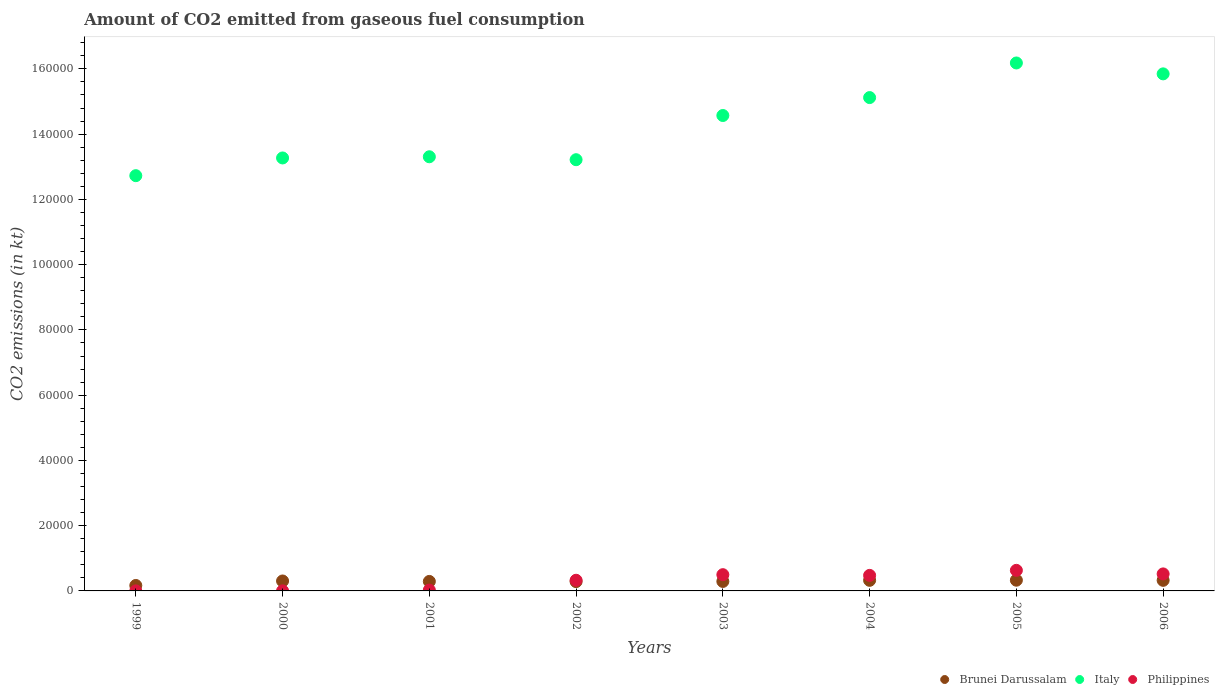What is the amount of CO2 emitted in Brunei Darussalam in 2002?
Give a very brief answer. 2852.93. Across all years, what is the maximum amount of CO2 emitted in Italy?
Provide a short and direct response. 1.62e+05. Across all years, what is the minimum amount of CO2 emitted in Italy?
Offer a very short reply. 1.27e+05. In which year was the amount of CO2 emitted in Philippines maximum?
Ensure brevity in your answer.  2005. What is the total amount of CO2 emitted in Italy in the graph?
Your answer should be compact. 1.14e+06. What is the difference between the amount of CO2 emitted in Brunei Darussalam in 2004 and that in 2006?
Provide a short and direct response. 3.67. What is the difference between the amount of CO2 emitted in Italy in 2006 and the amount of CO2 emitted in Philippines in 1999?
Make the answer very short. 1.58e+05. What is the average amount of CO2 emitted in Brunei Darussalam per year?
Offer a very short reply. 2894.18. In the year 2006, what is the difference between the amount of CO2 emitted in Italy and amount of CO2 emitted in Brunei Darussalam?
Your answer should be very brief. 1.55e+05. In how many years, is the amount of CO2 emitted in Brunei Darussalam greater than 16000 kt?
Provide a short and direct response. 0. What is the ratio of the amount of CO2 emitted in Philippines in 2001 to that in 2002?
Provide a short and direct response. 0.08. Is the difference between the amount of CO2 emitted in Italy in 2001 and 2006 greater than the difference between the amount of CO2 emitted in Brunei Darussalam in 2001 and 2006?
Your answer should be compact. No. What is the difference between the highest and the second highest amount of CO2 emitted in Brunei Darussalam?
Give a very brief answer. 40.34. What is the difference between the highest and the lowest amount of CO2 emitted in Italy?
Your answer should be very brief. 3.45e+04. In how many years, is the amount of CO2 emitted in Brunei Darussalam greater than the average amount of CO2 emitted in Brunei Darussalam taken over all years?
Provide a succinct answer. 6. Does the amount of CO2 emitted in Italy monotonically increase over the years?
Keep it short and to the point. No. Is the amount of CO2 emitted in Brunei Darussalam strictly less than the amount of CO2 emitted in Philippines over the years?
Provide a short and direct response. No. How many dotlines are there?
Provide a succinct answer. 3. How many years are there in the graph?
Keep it short and to the point. 8. What is the difference between two consecutive major ticks on the Y-axis?
Ensure brevity in your answer.  2.00e+04. Does the graph contain any zero values?
Your answer should be very brief. No. Does the graph contain grids?
Offer a very short reply. No. Where does the legend appear in the graph?
Your answer should be very brief. Bottom right. What is the title of the graph?
Your answer should be very brief. Amount of CO2 emitted from gaseous fuel consumption. What is the label or title of the X-axis?
Keep it short and to the point. Years. What is the label or title of the Y-axis?
Make the answer very short. CO2 emissions (in kt). What is the CO2 emissions (in kt) in Brunei Darussalam in 1999?
Provide a succinct answer. 1668.48. What is the CO2 emissions (in kt) in Italy in 1999?
Offer a terse response. 1.27e+05. What is the CO2 emissions (in kt) of Philippines in 1999?
Provide a succinct answer. 14.67. What is the CO2 emissions (in kt) in Brunei Darussalam in 2000?
Offer a very short reply. 3047.28. What is the CO2 emissions (in kt) of Italy in 2000?
Provide a short and direct response. 1.33e+05. What is the CO2 emissions (in kt) in Philippines in 2000?
Your response must be concise. 18.34. What is the CO2 emissions (in kt) in Brunei Darussalam in 2001?
Your response must be concise. 2907.93. What is the CO2 emissions (in kt) of Italy in 2001?
Offer a terse response. 1.33e+05. What is the CO2 emissions (in kt) of Philippines in 2001?
Your answer should be compact. 260.36. What is the CO2 emissions (in kt) in Brunei Darussalam in 2002?
Ensure brevity in your answer.  2852.93. What is the CO2 emissions (in kt) in Italy in 2002?
Give a very brief answer. 1.32e+05. What is the CO2 emissions (in kt) in Philippines in 2002?
Keep it short and to the point. 3267.3. What is the CO2 emissions (in kt) of Brunei Darussalam in 2003?
Provide a succinct answer. 2904.26. What is the CO2 emissions (in kt) in Italy in 2003?
Provide a succinct answer. 1.46e+05. What is the CO2 emissions (in kt) in Philippines in 2003?
Ensure brevity in your answer.  4979.79. What is the CO2 emissions (in kt) of Brunei Darussalam in 2004?
Your answer should be very brief. 3245.3. What is the CO2 emissions (in kt) in Italy in 2004?
Keep it short and to the point. 1.51e+05. What is the CO2 emissions (in kt) of Philippines in 2004?
Your answer should be very brief. 4763.43. What is the CO2 emissions (in kt) in Brunei Darussalam in 2005?
Your response must be concise. 3285.63. What is the CO2 emissions (in kt) in Italy in 2005?
Make the answer very short. 1.62e+05. What is the CO2 emissions (in kt) in Philippines in 2005?
Give a very brief answer. 6307.24. What is the CO2 emissions (in kt) of Brunei Darussalam in 2006?
Offer a very short reply. 3241.63. What is the CO2 emissions (in kt) in Italy in 2006?
Your answer should be compact. 1.58e+05. What is the CO2 emissions (in kt) of Philippines in 2006?
Make the answer very short. 5214.47. Across all years, what is the maximum CO2 emissions (in kt) of Brunei Darussalam?
Offer a terse response. 3285.63. Across all years, what is the maximum CO2 emissions (in kt) of Italy?
Your response must be concise. 1.62e+05. Across all years, what is the maximum CO2 emissions (in kt) of Philippines?
Ensure brevity in your answer.  6307.24. Across all years, what is the minimum CO2 emissions (in kt) in Brunei Darussalam?
Make the answer very short. 1668.48. Across all years, what is the minimum CO2 emissions (in kt) of Italy?
Make the answer very short. 1.27e+05. Across all years, what is the minimum CO2 emissions (in kt) of Philippines?
Your response must be concise. 14.67. What is the total CO2 emissions (in kt) of Brunei Darussalam in the graph?
Ensure brevity in your answer.  2.32e+04. What is the total CO2 emissions (in kt) in Italy in the graph?
Provide a succinct answer. 1.14e+06. What is the total CO2 emissions (in kt) in Philippines in the graph?
Your response must be concise. 2.48e+04. What is the difference between the CO2 emissions (in kt) in Brunei Darussalam in 1999 and that in 2000?
Keep it short and to the point. -1378.79. What is the difference between the CO2 emissions (in kt) of Italy in 1999 and that in 2000?
Your answer should be very brief. -5430.83. What is the difference between the CO2 emissions (in kt) of Philippines in 1999 and that in 2000?
Give a very brief answer. -3.67. What is the difference between the CO2 emissions (in kt) in Brunei Darussalam in 1999 and that in 2001?
Offer a terse response. -1239.45. What is the difference between the CO2 emissions (in kt) of Italy in 1999 and that in 2001?
Ensure brevity in your answer.  -5793.86. What is the difference between the CO2 emissions (in kt) of Philippines in 1999 and that in 2001?
Ensure brevity in your answer.  -245.69. What is the difference between the CO2 emissions (in kt) in Brunei Darussalam in 1999 and that in 2002?
Provide a succinct answer. -1184.44. What is the difference between the CO2 emissions (in kt) in Italy in 1999 and that in 2002?
Provide a succinct answer. -4895.44. What is the difference between the CO2 emissions (in kt) in Philippines in 1999 and that in 2002?
Provide a short and direct response. -3252.63. What is the difference between the CO2 emissions (in kt) of Brunei Darussalam in 1999 and that in 2003?
Your response must be concise. -1235.78. What is the difference between the CO2 emissions (in kt) of Italy in 1999 and that in 2003?
Keep it short and to the point. -1.84e+04. What is the difference between the CO2 emissions (in kt) of Philippines in 1999 and that in 2003?
Keep it short and to the point. -4965.12. What is the difference between the CO2 emissions (in kt) of Brunei Darussalam in 1999 and that in 2004?
Give a very brief answer. -1576.81. What is the difference between the CO2 emissions (in kt) in Italy in 1999 and that in 2004?
Ensure brevity in your answer.  -2.39e+04. What is the difference between the CO2 emissions (in kt) of Philippines in 1999 and that in 2004?
Your answer should be compact. -4748.77. What is the difference between the CO2 emissions (in kt) in Brunei Darussalam in 1999 and that in 2005?
Offer a very short reply. -1617.15. What is the difference between the CO2 emissions (in kt) in Italy in 1999 and that in 2005?
Offer a terse response. -3.45e+04. What is the difference between the CO2 emissions (in kt) of Philippines in 1999 and that in 2005?
Provide a succinct answer. -6292.57. What is the difference between the CO2 emissions (in kt) in Brunei Darussalam in 1999 and that in 2006?
Offer a terse response. -1573.14. What is the difference between the CO2 emissions (in kt) of Italy in 1999 and that in 2006?
Offer a very short reply. -3.12e+04. What is the difference between the CO2 emissions (in kt) of Philippines in 1999 and that in 2006?
Your answer should be compact. -5199.81. What is the difference between the CO2 emissions (in kt) of Brunei Darussalam in 2000 and that in 2001?
Give a very brief answer. 139.35. What is the difference between the CO2 emissions (in kt) in Italy in 2000 and that in 2001?
Your answer should be compact. -363.03. What is the difference between the CO2 emissions (in kt) in Philippines in 2000 and that in 2001?
Keep it short and to the point. -242.02. What is the difference between the CO2 emissions (in kt) of Brunei Darussalam in 2000 and that in 2002?
Provide a succinct answer. 194.35. What is the difference between the CO2 emissions (in kt) in Italy in 2000 and that in 2002?
Your answer should be very brief. 535.38. What is the difference between the CO2 emissions (in kt) of Philippines in 2000 and that in 2002?
Provide a succinct answer. -3248.96. What is the difference between the CO2 emissions (in kt) in Brunei Darussalam in 2000 and that in 2003?
Ensure brevity in your answer.  143.01. What is the difference between the CO2 emissions (in kt) of Italy in 2000 and that in 2003?
Offer a very short reply. -1.30e+04. What is the difference between the CO2 emissions (in kt) of Philippines in 2000 and that in 2003?
Offer a terse response. -4961.45. What is the difference between the CO2 emissions (in kt) of Brunei Darussalam in 2000 and that in 2004?
Offer a very short reply. -198.02. What is the difference between the CO2 emissions (in kt) in Italy in 2000 and that in 2004?
Your response must be concise. -1.85e+04. What is the difference between the CO2 emissions (in kt) of Philippines in 2000 and that in 2004?
Your response must be concise. -4745.1. What is the difference between the CO2 emissions (in kt) in Brunei Darussalam in 2000 and that in 2005?
Give a very brief answer. -238.35. What is the difference between the CO2 emissions (in kt) in Italy in 2000 and that in 2005?
Offer a terse response. -2.91e+04. What is the difference between the CO2 emissions (in kt) of Philippines in 2000 and that in 2005?
Offer a very short reply. -6288.9. What is the difference between the CO2 emissions (in kt) in Brunei Darussalam in 2000 and that in 2006?
Keep it short and to the point. -194.35. What is the difference between the CO2 emissions (in kt) of Italy in 2000 and that in 2006?
Your response must be concise. -2.58e+04. What is the difference between the CO2 emissions (in kt) of Philippines in 2000 and that in 2006?
Your response must be concise. -5196.14. What is the difference between the CO2 emissions (in kt) of Brunei Darussalam in 2001 and that in 2002?
Provide a succinct answer. 55.01. What is the difference between the CO2 emissions (in kt) of Italy in 2001 and that in 2002?
Provide a succinct answer. 898.41. What is the difference between the CO2 emissions (in kt) in Philippines in 2001 and that in 2002?
Ensure brevity in your answer.  -3006.94. What is the difference between the CO2 emissions (in kt) of Brunei Darussalam in 2001 and that in 2003?
Offer a terse response. 3.67. What is the difference between the CO2 emissions (in kt) in Italy in 2001 and that in 2003?
Give a very brief answer. -1.26e+04. What is the difference between the CO2 emissions (in kt) in Philippines in 2001 and that in 2003?
Make the answer very short. -4719.43. What is the difference between the CO2 emissions (in kt) in Brunei Darussalam in 2001 and that in 2004?
Your response must be concise. -337.36. What is the difference between the CO2 emissions (in kt) in Italy in 2001 and that in 2004?
Give a very brief answer. -1.81e+04. What is the difference between the CO2 emissions (in kt) of Philippines in 2001 and that in 2004?
Give a very brief answer. -4503.08. What is the difference between the CO2 emissions (in kt) of Brunei Darussalam in 2001 and that in 2005?
Give a very brief answer. -377.7. What is the difference between the CO2 emissions (in kt) in Italy in 2001 and that in 2005?
Give a very brief answer. -2.87e+04. What is the difference between the CO2 emissions (in kt) in Philippines in 2001 and that in 2005?
Offer a very short reply. -6046.88. What is the difference between the CO2 emissions (in kt) of Brunei Darussalam in 2001 and that in 2006?
Make the answer very short. -333.7. What is the difference between the CO2 emissions (in kt) in Italy in 2001 and that in 2006?
Keep it short and to the point. -2.54e+04. What is the difference between the CO2 emissions (in kt) in Philippines in 2001 and that in 2006?
Give a very brief answer. -4954.12. What is the difference between the CO2 emissions (in kt) of Brunei Darussalam in 2002 and that in 2003?
Provide a short and direct response. -51.34. What is the difference between the CO2 emissions (in kt) in Italy in 2002 and that in 2003?
Make the answer very short. -1.35e+04. What is the difference between the CO2 emissions (in kt) of Philippines in 2002 and that in 2003?
Your answer should be very brief. -1712.49. What is the difference between the CO2 emissions (in kt) in Brunei Darussalam in 2002 and that in 2004?
Offer a very short reply. -392.37. What is the difference between the CO2 emissions (in kt) of Italy in 2002 and that in 2004?
Provide a short and direct response. -1.90e+04. What is the difference between the CO2 emissions (in kt) in Philippines in 2002 and that in 2004?
Your response must be concise. -1496.14. What is the difference between the CO2 emissions (in kt) in Brunei Darussalam in 2002 and that in 2005?
Make the answer very short. -432.71. What is the difference between the CO2 emissions (in kt) of Italy in 2002 and that in 2005?
Provide a succinct answer. -2.96e+04. What is the difference between the CO2 emissions (in kt) of Philippines in 2002 and that in 2005?
Ensure brevity in your answer.  -3039.94. What is the difference between the CO2 emissions (in kt) in Brunei Darussalam in 2002 and that in 2006?
Offer a terse response. -388.7. What is the difference between the CO2 emissions (in kt) of Italy in 2002 and that in 2006?
Your response must be concise. -2.63e+04. What is the difference between the CO2 emissions (in kt) of Philippines in 2002 and that in 2006?
Provide a succinct answer. -1947.18. What is the difference between the CO2 emissions (in kt) of Brunei Darussalam in 2003 and that in 2004?
Provide a succinct answer. -341.03. What is the difference between the CO2 emissions (in kt) in Italy in 2003 and that in 2004?
Provide a succinct answer. -5493.17. What is the difference between the CO2 emissions (in kt) of Philippines in 2003 and that in 2004?
Your response must be concise. 216.35. What is the difference between the CO2 emissions (in kt) in Brunei Darussalam in 2003 and that in 2005?
Offer a terse response. -381.37. What is the difference between the CO2 emissions (in kt) of Italy in 2003 and that in 2005?
Give a very brief answer. -1.61e+04. What is the difference between the CO2 emissions (in kt) of Philippines in 2003 and that in 2005?
Your response must be concise. -1327.45. What is the difference between the CO2 emissions (in kt) in Brunei Darussalam in 2003 and that in 2006?
Give a very brief answer. -337.36. What is the difference between the CO2 emissions (in kt) of Italy in 2003 and that in 2006?
Ensure brevity in your answer.  -1.28e+04. What is the difference between the CO2 emissions (in kt) in Philippines in 2003 and that in 2006?
Give a very brief answer. -234.69. What is the difference between the CO2 emissions (in kt) in Brunei Darussalam in 2004 and that in 2005?
Offer a terse response. -40.34. What is the difference between the CO2 emissions (in kt) in Italy in 2004 and that in 2005?
Your answer should be very brief. -1.06e+04. What is the difference between the CO2 emissions (in kt) of Philippines in 2004 and that in 2005?
Offer a terse response. -1543.81. What is the difference between the CO2 emissions (in kt) in Brunei Darussalam in 2004 and that in 2006?
Provide a succinct answer. 3.67. What is the difference between the CO2 emissions (in kt) in Italy in 2004 and that in 2006?
Ensure brevity in your answer.  -7267.99. What is the difference between the CO2 emissions (in kt) in Philippines in 2004 and that in 2006?
Make the answer very short. -451.04. What is the difference between the CO2 emissions (in kt) in Brunei Darussalam in 2005 and that in 2006?
Make the answer very short. 44. What is the difference between the CO2 emissions (in kt) in Italy in 2005 and that in 2006?
Offer a very short reply. 3340.64. What is the difference between the CO2 emissions (in kt) of Philippines in 2005 and that in 2006?
Ensure brevity in your answer.  1092.77. What is the difference between the CO2 emissions (in kt) of Brunei Darussalam in 1999 and the CO2 emissions (in kt) of Italy in 2000?
Ensure brevity in your answer.  -1.31e+05. What is the difference between the CO2 emissions (in kt) of Brunei Darussalam in 1999 and the CO2 emissions (in kt) of Philippines in 2000?
Provide a succinct answer. 1650.15. What is the difference between the CO2 emissions (in kt) in Italy in 1999 and the CO2 emissions (in kt) in Philippines in 2000?
Your answer should be very brief. 1.27e+05. What is the difference between the CO2 emissions (in kt) of Brunei Darussalam in 1999 and the CO2 emissions (in kt) of Italy in 2001?
Keep it short and to the point. -1.31e+05. What is the difference between the CO2 emissions (in kt) in Brunei Darussalam in 1999 and the CO2 emissions (in kt) in Philippines in 2001?
Ensure brevity in your answer.  1408.13. What is the difference between the CO2 emissions (in kt) of Italy in 1999 and the CO2 emissions (in kt) of Philippines in 2001?
Provide a short and direct response. 1.27e+05. What is the difference between the CO2 emissions (in kt) of Brunei Darussalam in 1999 and the CO2 emissions (in kt) of Italy in 2002?
Your response must be concise. -1.30e+05. What is the difference between the CO2 emissions (in kt) in Brunei Darussalam in 1999 and the CO2 emissions (in kt) in Philippines in 2002?
Provide a short and direct response. -1598.81. What is the difference between the CO2 emissions (in kt) of Italy in 1999 and the CO2 emissions (in kt) of Philippines in 2002?
Give a very brief answer. 1.24e+05. What is the difference between the CO2 emissions (in kt) in Brunei Darussalam in 1999 and the CO2 emissions (in kt) in Italy in 2003?
Make the answer very short. -1.44e+05. What is the difference between the CO2 emissions (in kt) of Brunei Darussalam in 1999 and the CO2 emissions (in kt) of Philippines in 2003?
Make the answer very short. -3311.3. What is the difference between the CO2 emissions (in kt) of Italy in 1999 and the CO2 emissions (in kt) of Philippines in 2003?
Provide a succinct answer. 1.22e+05. What is the difference between the CO2 emissions (in kt) in Brunei Darussalam in 1999 and the CO2 emissions (in kt) in Italy in 2004?
Your answer should be compact. -1.50e+05. What is the difference between the CO2 emissions (in kt) of Brunei Darussalam in 1999 and the CO2 emissions (in kt) of Philippines in 2004?
Your response must be concise. -3094.95. What is the difference between the CO2 emissions (in kt) of Italy in 1999 and the CO2 emissions (in kt) of Philippines in 2004?
Give a very brief answer. 1.23e+05. What is the difference between the CO2 emissions (in kt) in Brunei Darussalam in 1999 and the CO2 emissions (in kt) in Italy in 2005?
Offer a very short reply. -1.60e+05. What is the difference between the CO2 emissions (in kt) of Brunei Darussalam in 1999 and the CO2 emissions (in kt) of Philippines in 2005?
Provide a short and direct response. -4638.76. What is the difference between the CO2 emissions (in kt) of Italy in 1999 and the CO2 emissions (in kt) of Philippines in 2005?
Ensure brevity in your answer.  1.21e+05. What is the difference between the CO2 emissions (in kt) of Brunei Darussalam in 1999 and the CO2 emissions (in kt) of Italy in 2006?
Give a very brief answer. -1.57e+05. What is the difference between the CO2 emissions (in kt) in Brunei Darussalam in 1999 and the CO2 emissions (in kt) in Philippines in 2006?
Ensure brevity in your answer.  -3545.99. What is the difference between the CO2 emissions (in kt) of Italy in 1999 and the CO2 emissions (in kt) of Philippines in 2006?
Your answer should be very brief. 1.22e+05. What is the difference between the CO2 emissions (in kt) of Brunei Darussalam in 2000 and the CO2 emissions (in kt) of Italy in 2001?
Offer a terse response. -1.30e+05. What is the difference between the CO2 emissions (in kt) in Brunei Darussalam in 2000 and the CO2 emissions (in kt) in Philippines in 2001?
Provide a succinct answer. 2786.92. What is the difference between the CO2 emissions (in kt) of Italy in 2000 and the CO2 emissions (in kt) of Philippines in 2001?
Offer a very short reply. 1.32e+05. What is the difference between the CO2 emissions (in kt) in Brunei Darussalam in 2000 and the CO2 emissions (in kt) in Italy in 2002?
Make the answer very short. -1.29e+05. What is the difference between the CO2 emissions (in kt) in Brunei Darussalam in 2000 and the CO2 emissions (in kt) in Philippines in 2002?
Ensure brevity in your answer.  -220.02. What is the difference between the CO2 emissions (in kt) in Italy in 2000 and the CO2 emissions (in kt) in Philippines in 2002?
Offer a very short reply. 1.29e+05. What is the difference between the CO2 emissions (in kt) in Brunei Darussalam in 2000 and the CO2 emissions (in kt) in Italy in 2003?
Your answer should be very brief. -1.43e+05. What is the difference between the CO2 emissions (in kt) of Brunei Darussalam in 2000 and the CO2 emissions (in kt) of Philippines in 2003?
Ensure brevity in your answer.  -1932.51. What is the difference between the CO2 emissions (in kt) of Italy in 2000 and the CO2 emissions (in kt) of Philippines in 2003?
Provide a succinct answer. 1.28e+05. What is the difference between the CO2 emissions (in kt) in Brunei Darussalam in 2000 and the CO2 emissions (in kt) in Italy in 2004?
Provide a short and direct response. -1.48e+05. What is the difference between the CO2 emissions (in kt) in Brunei Darussalam in 2000 and the CO2 emissions (in kt) in Philippines in 2004?
Provide a short and direct response. -1716.16. What is the difference between the CO2 emissions (in kt) of Italy in 2000 and the CO2 emissions (in kt) of Philippines in 2004?
Offer a very short reply. 1.28e+05. What is the difference between the CO2 emissions (in kt) of Brunei Darussalam in 2000 and the CO2 emissions (in kt) of Italy in 2005?
Provide a succinct answer. -1.59e+05. What is the difference between the CO2 emissions (in kt) of Brunei Darussalam in 2000 and the CO2 emissions (in kt) of Philippines in 2005?
Provide a short and direct response. -3259.96. What is the difference between the CO2 emissions (in kt) in Italy in 2000 and the CO2 emissions (in kt) in Philippines in 2005?
Provide a succinct answer. 1.26e+05. What is the difference between the CO2 emissions (in kt) of Brunei Darussalam in 2000 and the CO2 emissions (in kt) of Italy in 2006?
Your answer should be compact. -1.55e+05. What is the difference between the CO2 emissions (in kt) in Brunei Darussalam in 2000 and the CO2 emissions (in kt) in Philippines in 2006?
Give a very brief answer. -2167.2. What is the difference between the CO2 emissions (in kt) of Italy in 2000 and the CO2 emissions (in kt) of Philippines in 2006?
Your answer should be very brief. 1.27e+05. What is the difference between the CO2 emissions (in kt) of Brunei Darussalam in 2001 and the CO2 emissions (in kt) of Italy in 2002?
Give a very brief answer. -1.29e+05. What is the difference between the CO2 emissions (in kt) in Brunei Darussalam in 2001 and the CO2 emissions (in kt) in Philippines in 2002?
Make the answer very short. -359.37. What is the difference between the CO2 emissions (in kt) of Italy in 2001 and the CO2 emissions (in kt) of Philippines in 2002?
Give a very brief answer. 1.30e+05. What is the difference between the CO2 emissions (in kt) in Brunei Darussalam in 2001 and the CO2 emissions (in kt) in Italy in 2003?
Your answer should be very brief. -1.43e+05. What is the difference between the CO2 emissions (in kt) of Brunei Darussalam in 2001 and the CO2 emissions (in kt) of Philippines in 2003?
Your response must be concise. -2071.86. What is the difference between the CO2 emissions (in kt) in Italy in 2001 and the CO2 emissions (in kt) in Philippines in 2003?
Provide a succinct answer. 1.28e+05. What is the difference between the CO2 emissions (in kt) of Brunei Darussalam in 2001 and the CO2 emissions (in kt) of Italy in 2004?
Keep it short and to the point. -1.48e+05. What is the difference between the CO2 emissions (in kt) of Brunei Darussalam in 2001 and the CO2 emissions (in kt) of Philippines in 2004?
Offer a terse response. -1855.5. What is the difference between the CO2 emissions (in kt) in Italy in 2001 and the CO2 emissions (in kt) in Philippines in 2004?
Your response must be concise. 1.28e+05. What is the difference between the CO2 emissions (in kt) of Brunei Darussalam in 2001 and the CO2 emissions (in kt) of Italy in 2005?
Provide a short and direct response. -1.59e+05. What is the difference between the CO2 emissions (in kt) of Brunei Darussalam in 2001 and the CO2 emissions (in kt) of Philippines in 2005?
Keep it short and to the point. -3399.31. What is the difference between the CO2 emissions (in kt) in Italy in 2001 and the CO2 emissions (in kt) in Philippines in 2005?
Give a very brief answer. 1.27e+05. What is the difference between the CO2 emissions (in kt) in Brunei Darussalam in 2001 and the CO2 emissions (in kt) in Italy in 2006?
Give a very brief answer. -1.56e+05. What is the difference between the CO2 emissions (in kt) of Brunei Darussalam in 2001 and the CO2 emissions (in kt) of Philippines in 2006?
Your response must be concise. -2306.54. What is the difference between the CO2 emissions (in kt) in Italy in 2001 and the CO2 emissions (in kt) in Philippines in 2006?
Offer a very short reply. 1.28e+05. What is the difference between the CO2 emissions (in kt) in Brunei Darussalam in 2002 and the CO2 emissions (in kt) in Italy in 2003?
Provide a succinct answer. -1.43e+05. What is the difference between the CO2 emissions (in kt) in Brunei Darussalam in 2002 and the CO2 emissions (in kt) in Philippines in 2003?
Give a very brief answer. -2126.86. What is the difference between the CO2 emissions (in kt) of Italy in 2002 and the CO2 emissions (in kt) of Philippines in 2003?
Make the answer very short. 1.27e+05. What is the difference between the CO2 emissions (in kt) in Brunei Darussalam in 2002 and the CO2 emissions (in kt) in Italy in 2004?
Keep it short and to the point. -1.48e+05. What is the difference between the CO2 emissions (in kt) in Brunei Darussalam in 2002 and the CO2 emissions (in kt) in Philippines in 2004?
Provide a succinct answer. -1910.51. What is the difference between the CO2 emissions (in kt) in Italy in 2002 and the CO2 emissions (in kt) in Philippines in 2004?
Your response must be concise. 1.27e+05. What is the difference between the CO2 emissions (in kt) in Brunei Darussalam in 2002 and the CO2 emissions (in kt) in Italy in 2005?
Your response must be concise. -1.59e+05. What is the difference between the CO2 emissions (in kt) of Brunei Darussalam in 2002 and the CO2 emissions (in kt) of Philippines in 2005?
Provide a short and direct response. -3454.31. What is the difference between the CO2 emissions (in kt) of Italy in 2002 and the CO2 emissions (in kt) of Philippines in 2005?
Keep it short and to the point. 1.26e+05. What is the difference between the CO2 emissions (in kt) of Brunei Darussalam in 2002 and the CO2 emissions (in kt) of Italy in 2006?
Make the answer very short. -1.56e+05. What is the difference between the CO2 emissions (in kt) in Brunei Darussalam in 2002 and the CO2 emissions (in kt) in Philippines in 2006?
Keep it short and to the point. -2361.55. What is the difference between the CO2 emissions (in kt) in Italy in 2002 and the CO2 emissions (in kt) in Philippines in 2006?
Provide a succinct answer. 1.27e+05. What is the difference between the CO2 emissions (in kt) of Brunei Darussalam in 2003 and the CO2 emissions (in kt) of Italy in 2004?
Your response must be concise. -1.48e+05. What is the difference between the CO2 emissions (in kt) of Brunei Darussalam in 2003 and the CO2 emissions (in kt) of Philippines in 2004?
Your answer should be very brief. -1859.17. What is the difference between the CO2 emissions (in kt) of Italy in 2003 and the CO2 emissions (in kt) of Philippines in 2004?
Your answer should be very brief. 1.41e+05. What is the difference between the CO2 emissions (in kt) in Brunei Darussalam in 2003 and the CO2 emissions (in kt) in Italy in 2005?
Provide a succinct answer. -1.59e+05. What is the difference between the CO2 emissions (in kt) in Brunei Darussalam in 2003 and the CO2 emissions (in kt) in Philippines in 2005?
Offer a terse response. -3402.98. What is the difference between the CO2 emissions (in kt) in Italy in 2003 and the CO2 emissions (in kt) in Philippines in 2005?
Provide a short and direct response. 1.39e+05. What is the difference between the CO2 emissions (in kt) in Brunei Darussalam in 2003 and the CO2 emissions (in kt) in Italy in 2006?
Your answer should be very brief. -1.56e+05. What is the difference between the CO2 emissions (in kt) in Brunei Darussalam in 2003 and the CO2 emissions (in kt) in Philippines in 2006?
Make the answer very short. -2310.21. What is the difference between the CO2 emissions (in kt) in Italy in 2003 and the CO2 emissions (in kt) in Philippines in 2006?
Offer a very short reply. 1.40e+05. What is the difference between the CO2 emissions (in kt) of Brunei Darussalam in 2004 and the CO2 emissions (in kt) of Italy in 2005?
Keep it short and to the point. -1.59e+05. What is the difference between the CO2 emissions (in kt) in Brunei Darussalam in 2004 and the CO2 emissions (in kt) in Philippines in 2005?
Your answer should be compact. -3061.95. What is the difference between the CO2 emissions (in kt) in Italy in 2004 and the CO2 emissions (in kt) in Philippines in 2005?
Your answer should be very brief. 1.45e+05. What is the difference between the CO2 emissions (in kt) of Brunei Darussalam in 2004 and the CO2 emissions (in kt) of Italy in 2006?
Your answer should be compact. -1.55e+05. What is the difference between the CO2 emissions (in kt) of Brunei Darussalam in 2004 and the CO2 emissions (in kt) of Philippines in 2006?
Your answer should be very brief. -1969.18. What is the difference between the CO2 emissions (in kt) in Italy in 2004 and the CO2 emissions (in kt) in Philippines in 2006?
Make the answer very short. 1.46e+05. What is the difference between the CO2 emissions (in kt) in Brunei Darussalam in 2005 and the CO2 emissions (in kt) in Italy in 2006?
Provide a succinct answer. -1.55e+05. What is the difference between the CO2 emissions (in kt) in Brunei Darussalam in 2005 and the CO2 emissions (in kt) in Philippines in 2006?
Offer a terse response. -1928.84. What is the difference between the CO2 emissions (in kt) of Italy in 2005 and the CO2 emissions (in kt) of Philippines in 2006?
Provide a succinct answer. 1.57e+05. What is the average CO2 emissions (in kt) in Brunei Darussalam per year?
Provide a short and direct response. 2894.18. What is the average CO2 emissions (in kt) in Italy per year?
Give a very brief answer. 1.43e+05. What is the average CO2 emissions (in kt) of Philippines per year?
Give a very brief answer. 3103.2. In the year 1999, what is the difference between the CO2 emissions (in kt) of Brunei Darussalam and CO2 emissions (in kt) of Italy?
Ensure brevity in your answer.  -1.26e+05. In the year 1999, what is the difference between the CO2 emissions (in kt) in Brunei Darussalam and CO2 emissions (in kt) in Philippines?
Make the answer very short. 1653.82. In the year 1999, what is the difference between the CO2 emissions (in kt) in Italy and CO2 emissions (in kt) in Philippines?
Offer a terse response. 1.27e+05. In the year 2000, what is the difference between the CO2 emissions (in kt) in Brunei Darussalam and CO2 emissions (in kt) in Italy?
Your response must be concise. -1.30e+05. In the year 2000, what is the difference between the CO2 emissions (in kt) in Brunei Darussalam and CO2 emissions (in kt) in Philippines?
Provide a short and direct response. 3028.94. In the year 2000, what is the difference between the CO2 emissions (in kt) in Italy and CO2 emissions (in kt) in Philippines?
Offer a terse response. 1.33e+05. In the year 2001, what is the difference between the CO2 emissions (in kt) in Brunei Darussalam and CO2 emissions (in kt) in Italy?
Provide a succinct answer. -1.30e+05. In the year 2001, what is the difference between the CO2 emissions (in kt) of Brunei Darussalam and CO2 emissions (in kt) of Philippines?
Your response must be concise. 2647.57. In the year 2001, what is the difference between the CO2 emissions (in kt) in Italy and CO2 emissions (in kt) in Philippines?
Your answer should be compact. 1.33e+05. In the year 2002, what is the difference between the CO2 emissions (in kt) of Brunei Darussalam and CO2 emissions (in kt) of Italy?
Give a very brief answer. -1.29e+05. In the year 2002, what is the difference between the CO2 emissions (in kt) of Brunei Darussalam and CO2 emissions (in kt) of Philippines?
Offer a very short reply. -414.37. In the year 2002, what is the difference between the CO2 emissions (in kt) of Italy and CO2 emissions (in kt) of Philippines?
Your answer should be compact. 1.29e+05. In the year 2003, what is the difference between the CO2 emissions (in kt) of Brunei Darussalam and CO2 emissions (in kt) of Italy?
Ensure brevity in your answer.  -1.43e+05. In the year 2003, what is the difference between the CO2 emissions (in kt) in Brunei Darussalam and CO2 emissions (in kt) in Philippines?
Give a very brief answer. -2075.52. In the year 2003, what is the difference between the CO2 emissions (in kt) of Italy and CO2 emissions (in kt) of Philippines?
Your answer should be very brief. 1.41e+05. In the year 2004, what is the difference between the CO2 emissions (in kt) in Brunei Darussalam and CO2 emissions (in kt) in Italy?
Provide a short and direct response. -1.48e+05. In the year 2004, what is the difference between the CO2 emissions (in kt) in Brunei Darussalam and CO2 emissions (in kt) in Philippines?
Offer a terse response. -1518.14. In the year 2004, what is the difference between the CO2 emissions (in kt) in Italy and CO2 emissions (in kt) in Philippines?
Provide a succinct answer. 1.46e+05. In the year 2005, what is the difference between the CO2 emissions (in kt) of Brunei Darussalam and CO2 emissions (in kt) of Italy?
Ensure brevity in your answer.  -1.59e+05. In the year 2005, what is the difference between the CO2 emissions (in kt) of Brunei Darussalam and CO2 emissions (in kt) of Philippines?
Your response must be concise. -3021.61. In the year 2005, what is the difference between the CO2 emissions (in kt) of Italy and CO2 emissions (in kt) of Philippines?
Your answer should be very brief. 1.56e+05. In the year 2006, what is the difference between the CO2 emissions (in kt) of Brunei Darussalam and CO2 emissions (in kt) of Italy?
Your answer should be very brief. -1.55e+05. In the year 2006, what is the difference between the CO2 emissions (in kt) in Brunei Darussalam and CO2 emissions (in kt) in Philippines?
Ensure brevity in your answer.  -1972.85. In the year 2006, what is the difference between the CO2 emissions (in kt) of Italy and CO2 emissions (in kt) of Philippines?
Give a very brief answer. 1.53e+05. What is the ratio of the CO2 emissions (in kt) in Brunei Darussalam in 1999 to that in 2000?
Your response must be concise. 0.55. What is the ratio of the CO2 emissions (in kt) in Italy in 1999 to that in 2000?
Give a very brief answer. 0.96. What is the ratio of the CO2 emissions (in kt) of Philippines in 1999 to that in 2000?
Provide a short and direct response. 0.8. What is the ratio of the CO2 emissions (in kt) of Brunei Darussalam in 1999 to that in 2001?
Provide a succinct answer. 0.57. What is the ratio of the CO2 emissions (in kt) of Italy in 1999 to that in 2001?
Give a very brief answer. 0.96. What is the ratio of the CO2 emissions (in kt) of Philippines in 1999 to that in 2001?
Provide a succinct answer. 0.06. What is the ratio of the CO2 emissions (in kt) in Brunei Darussalam in 1999 to that in 2002?
Your answer should be very brief. 0.58. What is the ratio of the CO2 emissions (in kt) of Philippines in 1999 to that in 2002?
Your answer should be compact. 0. What is the ratio of the CO2 emissions (in kt) of Brunei Darussalam in 1999 to that in 2003?
Offer a very short reply. 0.57. What is the ratio of the CO2 emissions (in kt) in Italy in 1999 to that in 2003?
Provide a short and direct response. 0.87. What is the ratio of the CO2 emissions (in kt) in Philippines in 1999 to that in 2003?
Give a very brief answer. 0. What is the ratio of the CO2 emissions (in kt) of Brunei Darussalam in 1999 to that in 2004?
Your answer should be compact. 0.51. What is the ratio of the CO2 emissions (in kt) of Italy in 1999 to that in 2004?
Your response must be concise. 0.84. What is the ratio of the CO2 emissions (in kt) in Philippines in 1999 to that in 2004?
Offer a very short reply. 0. What is the ratio of the CO2 emissions (in kt) in Brunei Darussalam in 1999 to that in 2005?
Offer a terse response. 0.51. What is the ratio of the CO2 emissions (in kt) in Italy in 1999 to that in 2005?
Provide a short and direct response. 0.79. What is the ratio of the CO2 emissions (in kt) in Philippines in 1999 to that in 2005?
Offer a terse response. 0. What is the ratio of the CO2 emissions (in kt) in Brunei Darussalam in 1999 to that in 2006?
Your response must be concise. 0.51. What is the ratio of the CO2 emissions (in kt) of Italy in 1999 to that in 2006?
Keep it short and to the point. 0.8. What is the ratio of the CO2 emissions (in kt) in Philippines in 1999 to that in 2006?
Make the answer very short. 0. What is the ratio of the CO2 emissions (in kt) of Brunei Darussalam in 2000 to that in 2001?
Keep it short and to the point. 1.05. What is the ratio of the CO2 emissions (in kt) of Italy in 2000 to that in 2001?
Your answer should be very brief. 1. What is the ratio of the CO2 emissions (in kt) in Philippines in 2000 to that in 2001?
Your answer should be compact. 0.07. What is the ratio of the CO2 emissions (in kt) in Brunei Darussalam in 2000 to that in 2002?
Ensure brevity in your answer.  1.07. What is the ratio of the CO2 emissions (in kt) of Philippines in 2000 to that in 2002?
Ensure brevity in your answer.  0.01. What is the ratio of the CO2 emissions (in kt) of Brunei Darussalam in 2000 to that in 2003?
Give a very brief answer. 1.05. What is the ratio of the CO2 emissions (in kt) of Italy in 2000 to that in 2003?
Make the answer very short. 0.91. What is the ratio of the CO2 emissions (in kt) in Philippines in 2000 to that in 2003?
Offer a very short reply. 0. What is the ratio of the CO2 emissions (in kt) of Brunei Darussalam in 2000 to that in 2004?
Offer a very short reply. 0.94. What is the ratio of the CO2 emissions (in kt) in Italy in 2000 to that in 2004?
Make the answer very short. 0.88. What is the ratio of the CO2 emissions (in kt) in Philippines in 2000 to that in 2004?
Keep it short and to the point. 0. What is the ratio of the CO2 emissions (in kt) of Brunei Darussalam in 2000 to that in 2005?
Make the answer very short. 0.93. What is the ratio of the CO2 emissions (in kt) of Italy in 2000 to that in 2005?
Provide a short and direct response. 0.82. What is the ratio of the CO2 emissions (in kt) of Philippines in 2000 to that in 2005?
Keep it short and to the point. 0. What is the ratio of the CO2 emissions (in kt) in Italy in 2000 to that in 2006?
Provide a succinct answer. 0.84. What is the ratio of the CO2 emissions (in kt) of Philippines in 2000 to that in 2006?
Your answer should be very brief. 0. What is the ratio of the CO2 emissions (in kt) of Brunei Darussalam in 2001 to that in 2002?
Make the answer very short. 1.02. What is the ratio of the CO2 emissions (in kt) in Italy in 2001 to that in 2002?
Ensure brevity in your answer.  1.01. What is the ratio of the CO2 emissions (in kt) of Philippines in 2001 to that in 2002?
Offer a terse response. 0.08. What is the ratio of the CO2 emissions (in kt) of Italy in 2001 to that in 2003?
Keep it short and to the point. 0.91. What is the ratio of the CO2 emissions (in kt) in Philippines in 2001 to that in 2003?
Your response must be concise. 0.05. What is the ratio of the CO2 emissions (in kt) of Brunei Darussalam in 2001 to that in 2004?
Your response must be concise. 0.9. What is the ratio of the CO2 emissions (in kt) in Philippines in 2001 to that in 2004?
Offer a terse response. 0.05. What is the ratio of the CO2 emissions (in kt) in Brunei Darussalam in 2001 to that in 2005?
Provide a succinct answer. 0.89. What is the ratio of the CO2 emissions (in kt) of Italy in 2001 to that in 2005?
Make the answer very short. 0.82. What is the ratio of the CO2 emissions (in kt) in Philippines in 2001 to that in 2005?
Offer a terse response. 0.04. What is the ratio of the CO2 emissions (in kt) in Brunei Darussalam in 2001 to that in 2006?
Provide a succinct answer. 0.9. What is the ratio of the CO2 emissions (in kt) in Italy in 2001 to that in 2006?
Keep it short and to the point. 0.84. What is the ratio of the CO2 emissions (in kt) in Philippines in 2001 to that in 2006?
Offer a terse response. 0.05. What is the ratio of the CO2 emissions (in kt) in Brunei Darussalam in 2002 to that in 2003?
Keep it short and to the point. 0.98. What is the ratio of the CO2 emissions (in kt) of Italy in 2002 to that in 2003?
Provide a succinct answer. 0.91. What is the ratio of the CO2 emissions (in kt) in Philippines in 2002 to that in 2003?
Provide a succinct answer. 0.66. What is the ratio of the CO2 emissions (in kt) of Brunei Darussalam in 2002 to that in 2004?
Ensure brevity in your answer.  0.88. What is the ratio of the CO2 emissions (in kt) of Italy in 2002 to that in 2004?
Your response must be concise. 0.87. What is the ratio of the CO2 emissions (in kt) in Philippines in 2002 to that in 2004?
Provide a short and direct response. 0.69. What is the ratio of the CO2 emissions (in kt) in Brunei Darussalam in 2002 to that in 2005?
Keep it short and to the point. 0.87. What is the ratio of the CO2 emissions (in kt) in Italy in 2002 to that in 2005?
Offer a terse response. 0.82. What is the ratio of the CO2 emissions (in kt) of Philippines in 2002 to that in 2005?
Give a very brief answer. 0.52. What is the ratio of the CO2 emissions (in kt) of Brunei Darussalam in 2002 to that in 2006?
Ensure brevity in your answer.  0.88. What is the ratio of the CO2 emissions (in kt) in Italy in 2002 to that in 2006?
Keep it short and to the point. 0.83. What is the ratio of the CO2 emissions (in kt) in Philippines in 2002 to that in 2006?
Make the answer very short. 0.63. What is the ratio of the CO2 emissions (in kt) in Brunei Darussalam in 2003 to that in 2004?
Provide a succinct answer. 0.89. What is the ratio of the CO2 emissions (in kt) in Italy in 2003 to that in 2004?
Offer a terse response. 0.96. What is the ratio of the CO2 emissions (in kt) of Philippines in 2003 to that in 2004?
Give a very brief answer. 1.05. What is the ratio of the CO2 emissions (in kt) in Brunei Darussalam in 2003 to that in 2005?
Your answer should be compact. 0.88. What is the ratio of the CO2 emissions (in kt) of Italy in 2003 to that in 2005?
Provide a short and direct response. 0.9. What is the ratio of the CO2 emissions (in kt) in Philippines in 2003 to that in 2005?
Keep it short and to the point. 0.79. What is the ratio of the CO2 emissions (in kt) in Brunei Darussalam in 2003 to that in 2006?
Keep it short and to the point. 0.9. What is the ratio of the CO2 emissions (in kt) of Italy in 2003 to that in 2006?
Provide a short and direct response. 0.92. What is the ratio of the CO2 emissions (in kt) in Philippines in 2003 to that in 2006?
Your answer should be very brief. 0.95. What is the ratio of the CO2 emissions (in kt) of Italy in 2004 to that in 2005?
Make the answer very short. 0.93. What is the ratio of the CO2 emissions (in kt) in Philippines in 2004 to that in 2005?
Your answer should be very brief. 0.76. What is the ratio of the CO2 emissions (in kt) of Brunei Darussalam in 2004 to that in 2006?
Provide a succinct answer. 1. What is the ratio of the CO2 emissions (in kt) in Italy in 2004 to that in 2006?
Provide a short and direct response. 0.95. What is the ratio of the CO2 emissions (in kt) of Philippines in 2004 to that in 2006?
Make the answer very short. 0.91. What is the ratio of the CO2 emissions (in kt) of Brunei Darussalam in 2005 to that in 2006?
Give a very brief answer. 1.01. What is the ratio of the CO2 emissions (in kt) in Italy in 2005 to that in 2006?
Your answer should be compact. 1.02. What is the ratio of the CO2 emissions (in kt) in Philippines in 2005 to that in 2006?
Your answer should be very brief. 1.21. What is the difference between the highest and the second highest CO2 emissions (in kt) of Brunei Darussalam?
Offer a very short reply. 40.34. What is the difference between the highest and the second highest CO2 emissions (in kt) in Italy?
Offer a terse response. 3340.64. What is the difference between the highest and the second highest CO2 emissions (in kt) of Philippines?
Keep it short and to the point. 1092.77. What is the difference between the highest and the lowest CO2 emissions (in kt) in Brunei Darussalam?
Provide a succinct answer. 1617.15. What is the difference between the highest and the lowest CO2 emissions (in kt) of Italy?
Your answer should be very brief. 3.45e+04. What is the difference between the highest and the lowest CO2 emissions (in kt) in Philippines?
Give a very brief answer. 6292.57. 